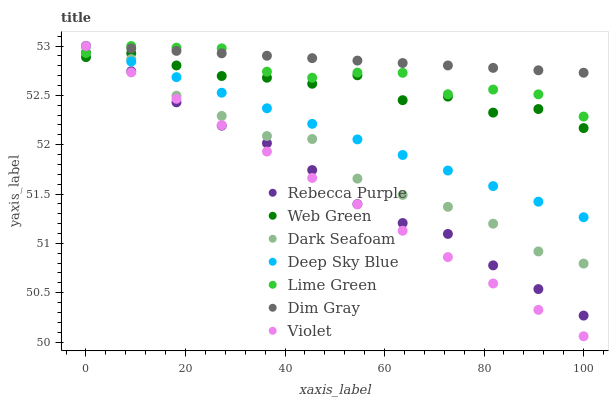Does Violet have the minimum area under the curve?
Answer yes or no. Yes. Does Dim Gray have the maximum area under the curve?
Answer yes or no. Yes. Does Web Green have the minimum area under the curve?
Answer yes or no. No. Does Web Green have the maximum area under the curve?
Answer yes or no. No. Is Deep Sky Blue the smoothest?
Answer yes or no. Yes. Is Web Green the roughest?
Answer yes or no. Yes. Is Dark Seafoam the smoothest?
Answer yes or no. No. Is Dark Seafoam the roughest?
Answer yes or no. No. Does Violet have the lowest value?
Answer yes or no. Yes. Does Web Green have the lowest value?
Answer yes or no. No. Does Lime Green have the highest value?
Answer yes or no. Yes. Does Web Green have the highest value?
Answer yes or no. No. Is Rebecca Purple less than Dark Seafoam?
Answer yes or no. Yes. Is Dim Gray greater than Web Green?
Answer yes or no. Yes. Does Web Green intersect Rebecca Purple?
Answer yes or no. Yes. Is Web Green less than Rebecca Purple?
Answer yes or no. No. Is Web Green greater than Rebecca Purple?
Answer yes or no. No. Does Rebecca Purple intersect Dark Seafoam?
Answer yes or no. No. 